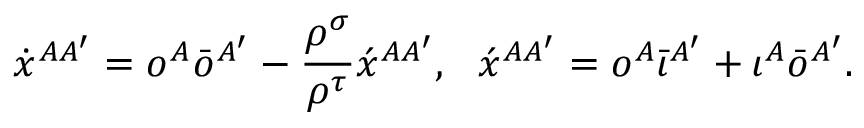Convert formula to latex. <formula><loc_0><loc_0><loc_500><loc_500>\dot { x } ^ { A A ^ { \prime } } = o ^ { A } \bar { o } ^ { A ^ { \prime } } - \frac { \rho ^ { \sigma } } { \rho ^ { \tau } } \acute { x } ^ { A A ^ { \prime } } , \, \acute { x } ^ { A A ^ { \prime } } = o ^ { A } \bar { \iota } ^ { A ^ { \prime } } + \iota ^ { A } \bar { o } ^ { A ^ { \prime } } .</formula> 